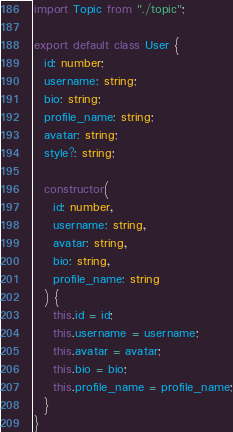<code> <loc_0><loc_0><loc_500><loc_500><_TypeScript_>import Topic from "./topic";

export default class User {
  id: number;
  username: string;
  bio: string;
  profile_name: string;
  avatar: string;
  style?: string;

  constructor(
    id: number,
    username: string,
    avatar: string,
    bio: string,
    profile_name: string
  ) {
    this.id = id;
    this.username = username;
    this.avatar = avatar;
    this.bio = bio;
    this.profile_name = profile_name;
  }
}
</code> 